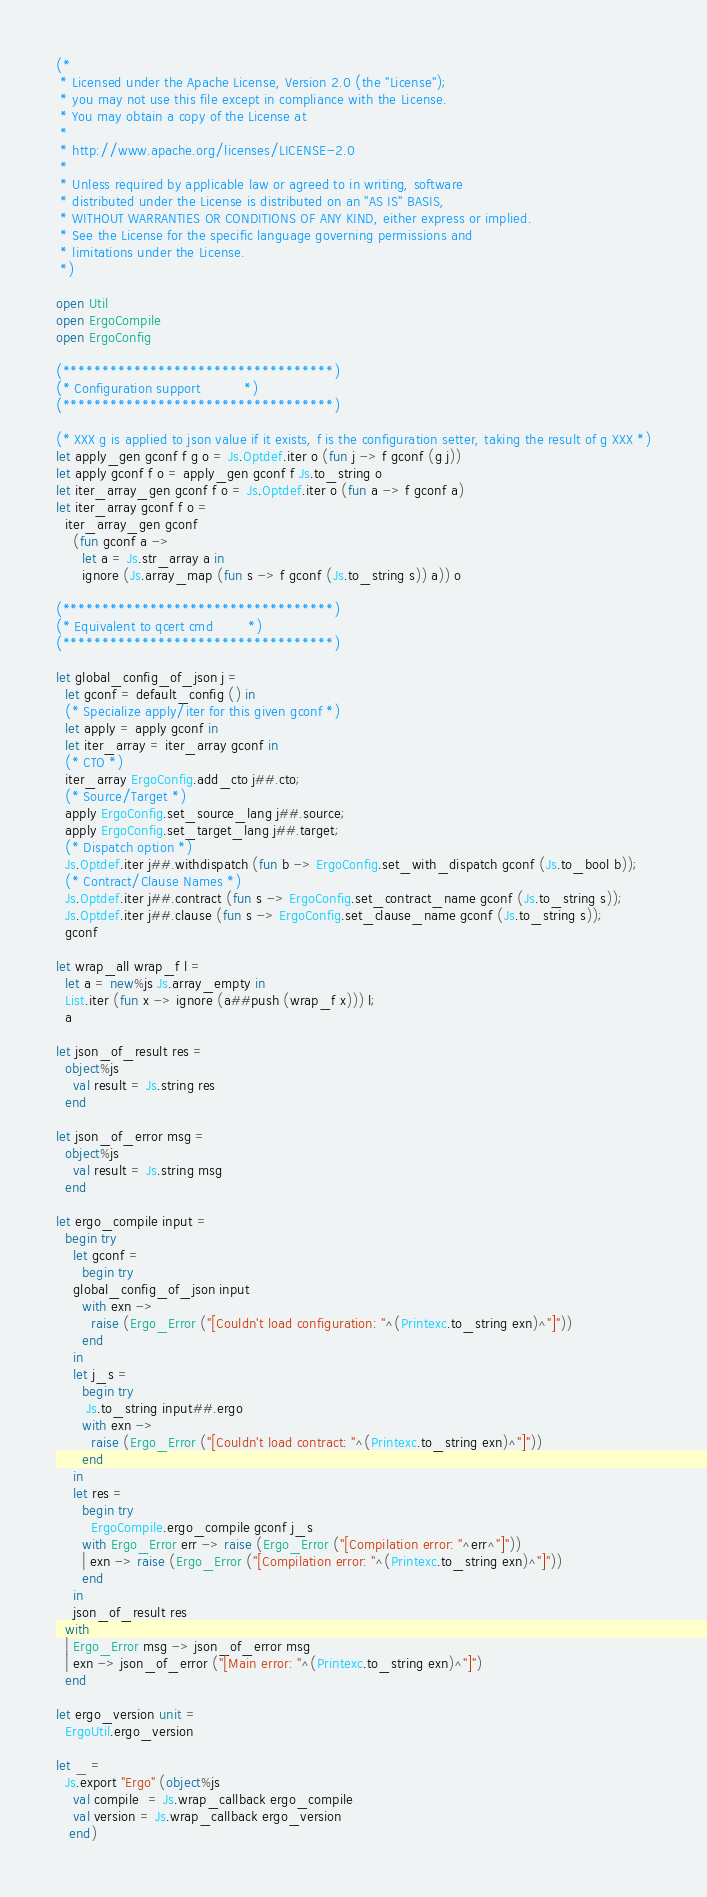<code> <loc_0><loc_0><loc_500><loc_500><_OCaml_>(*
 * Licensed under the Apache License, Version 2.0 (the "License");
 * you may not use this file except in compliance with the License.
 * You may obtain a copy of the License at
 *
 * http://www.apache.org/licenses/LICENSE-2.0
 *
 * Unless required by applicable law or agreed to in writing, software
 * distributed under the License is distributed on an "AS IS" BASIS,
 * WITHOUT WARRANTIES OR CONDITIONS OF ANY KIND, either express or implied.
 * See the License for the specific language governing permissions and
 * limitations under the License.
 *)

open Util
open ErgoCompile
open ErgoConfig

(**********************************)
(* Configuration support          *)
(**********************************)

(* XXX g is applied to json value if it exists, f is the configuration setter, taking the result of g XXX *)
let apply_gen gconf f g o = Js.Optdef.iter o (fun j -> f gconf (g j))
let apply gconf f o = apply_gen gconf f Js.to_string o
let iter_array_gen gconf f o = Js.Optdef.iter o (fun a -> f gconf a)
let iter_array gconf f o =
  iter_array_gen gconf
    (fun gconf a ->
      let a = Js.str_array a in
      ignore (Js.array_map (fun s -> f gconf (Js.to_string s)) a)) o

(**********************************)
(* Equivalent to qcert cmd        *)
(**********************************)

let global_config_of_json j =
  let gconf = default_config () in
  (* Specialize apply/iter for this given gconf *)
  let apply = apply gconf in
  let iter_array = iter_array gconf in
  (* CTO *)
  iter_array ErgoConfig.add_cto j##.cto;
  (* Source/Target *)
  apply ErgoConfig.set_source_lang j##.source;
  apply ErgoConfig.set_target_lang j##.target;
  (* Dispatch option *)
  Js.Optdef.iter j##.withdispatch (fun b -> ErgoConfig.set_with_dispatch gconf (Js.to_bool b));
  (* Contract/Clause Names *)
  Js.Optdef.iter j##.contract (fun s -> ErgoConfig.set_contract_name gconf (Js.to_string s));
  Js.Optdef.iter j##.clause (fun s -> ErgoConfig.set_clause_name gconf (Js.to_string s));
  gconf

let wrap_all wrap_f l =
  let a = new%js Js.array_empty in
  List.iter (fun x -> ignore (a##push (wrap_f x))) l;
  a

let json_of_result res =
  object%js
    val result = Js.string res
  end

let json_of_error msg =
  object%js
    val result = Js.string msg
  end

let ergo_compile input =
  begin try
    let gconf =
      begin try
	global_config_of_json input
      with exn ->
        raise (Ergo_Error ("[Couldn't load configuration: "^(Printexc.to_string exn)^"]"))
      end
    in
    let j_s =
      begin try
       Js.to_string input##.ergo
      with exn ->
        raise (Ergo_Error ("[Couldn't load contract: "^(Printexc.to_string exn)^"]"))
      end
    in
    let res =
      begin try
        ErgoCompile.ergo_compile gconf j_s
      with Ergo_Error err -> raise (Ergo_Error ("[Compilation error: "^err^"]"))
      | exn -> raise (Ergo_Error ("[Compilation error: "^(Printexc.to_string exn)^"]"))
      end
    in
    json_of_result res
  with
  | Ergo_Error msg -> json_of_error msg
  | exn -> json_of_error ("[Main error: "^(Printexc.to_string exn)^"]")
  end

let ergo_version unit =
  ErgoUtil.ergo_version

let _ =
  Js.export "Ergo" (object%js
    val compile  = Js.wrap_callback ergo_compile
    val version = Js.wrap_callback ergo_version
   end)
</code> 